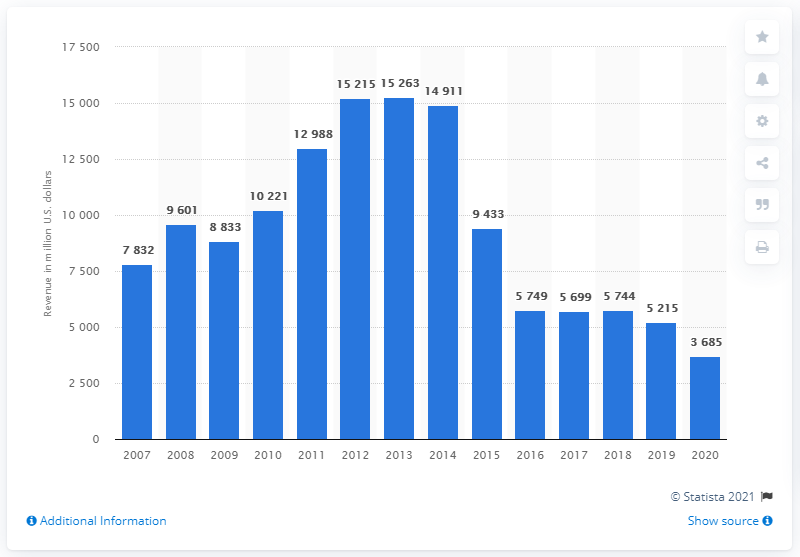Identify some key points in this picture. According to the provided information, Weatherford generated $36,850 in revenue in 2020. 